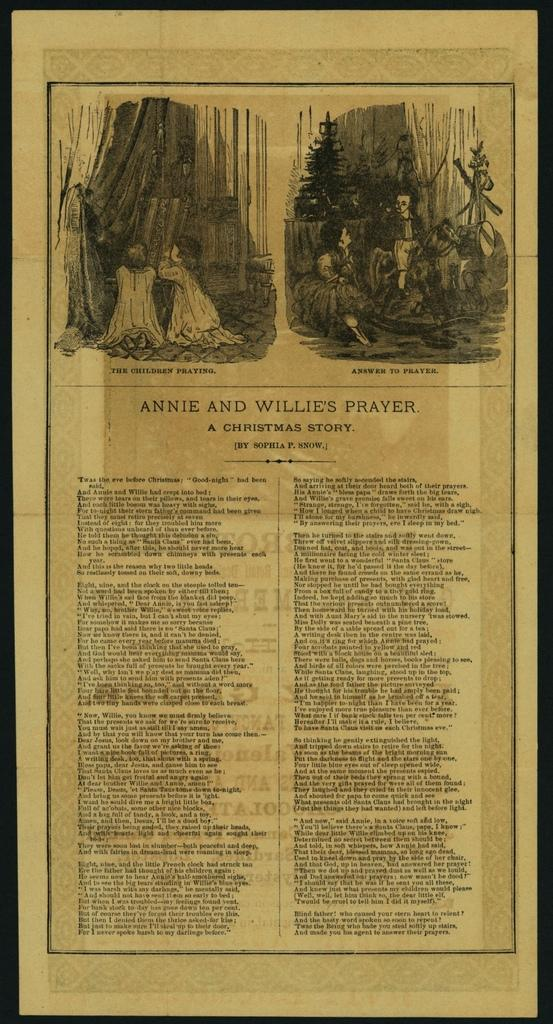What is present on the paper in the image? The paper contains images and words. Can you describe the images on the paper? Unfortunately, the specific images on the paper cannot be described without more information. What type of content is present on the paper? The paper contains both images and words, which suggests it might be a document, a flyer, or some other form of written communication. How does the jam on the paper contribute to the overall message? There is no jam present on the paper in the image. 